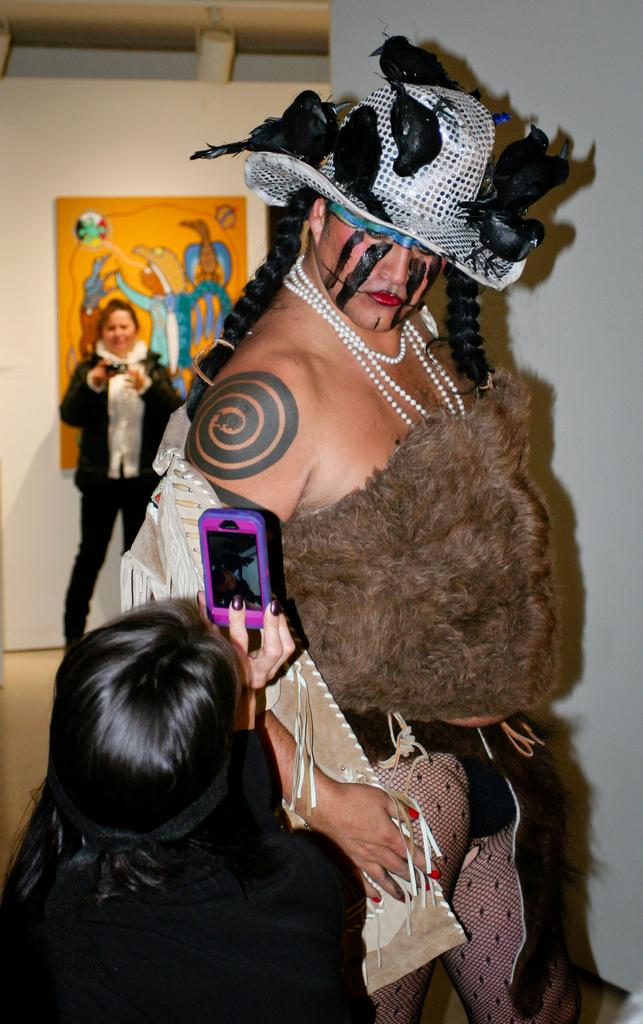What is the person in the image wearing? The person in the image is wearing a costume. What is the second person doing in the image? The second person is taking a picture with a mobile phone. How many people are present in the image? There are three people in the image. Can you describe the position of the third person in relation to the person wearing a costume? The third person is standing away from the person wearing a costume. What type of thread is being used to sew the costume in the image? There is no information about the type of thread used to sew the costume in the image. What is the aftermath of the event in the image? There is no event depicted in the image, so it is not possible to describe an aftermath. 